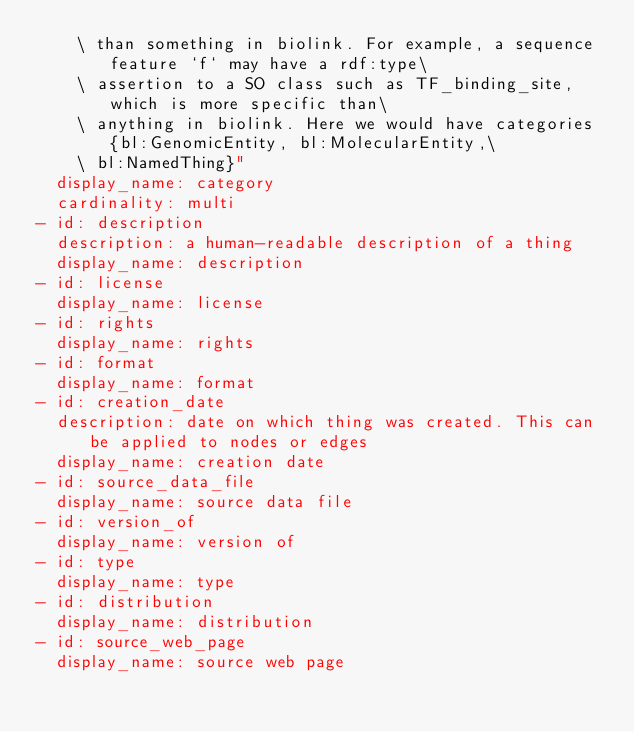Convert code to text. <code><loc_0><loc_0><loc_500><loc_500><_YAML_>    \ than something in biolink. For example, a sequence feature `f` may have a rdf:type\
    \ assertion to a SO class such as TF_binding_site, which is more specific than\
    \ anything in biolink. Here we would have categories {bl:GenomicEntity, bl:MolecularEntity,\
    \ bl:NamedThing}"
  display_name: category
  cardinality: multi
- id: description
  description: a human-readable description of a thing
  display_name: description
- id: license
  display_name: license
- id: rights
  display_name: rights
- id: format
  display_name: format
- id: creation_date
  description: date on which thing was created. This can be applied to nodes or edges
  display_name: creation date
- id: source_data_file
  display_name: source data file
- id: version_of
  display_name: version of
- id: type
  display_name: type
- id: distribution
  display_name: distribution
- id: source_web_page
  display_name: source web page
</code> 